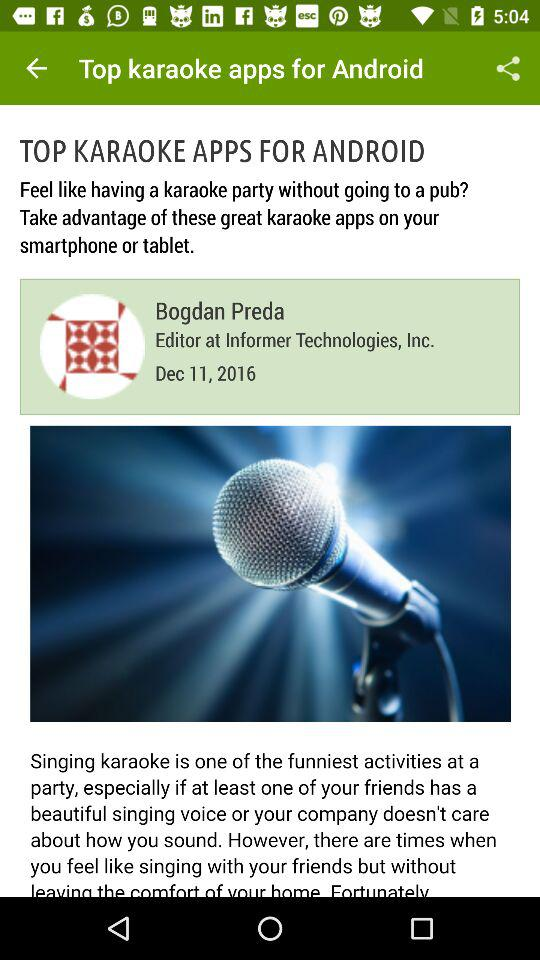What is the author name? The author name is Bogdan Preda. 